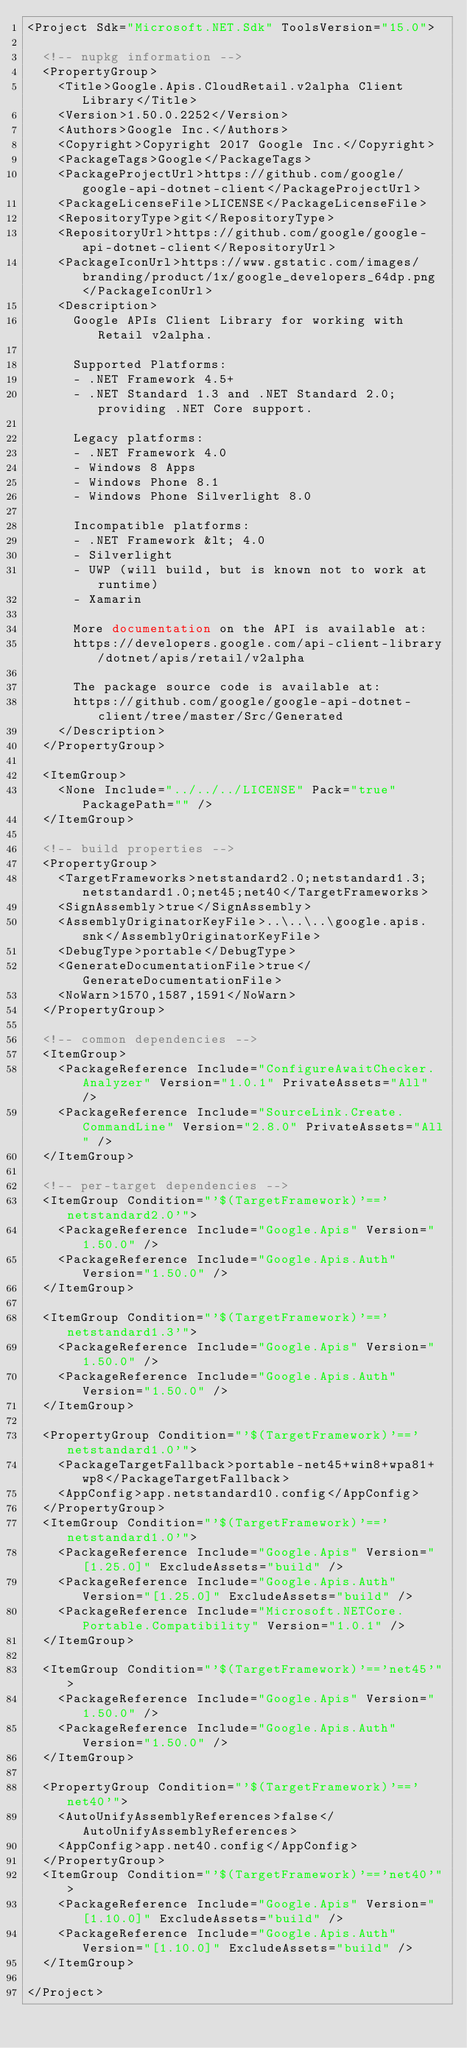<code> <loc_0><loc_0><loc_500><loc_500><_XML_><Project Sdk="Microsoft.NET.Sdk" ToolsVersion="15.0">

  <!-- nupkg information -->
  <PropertyGroup>
    <Title>Google.Apis.CloudRetail.v2alpha Client Library</Title>
    <Version>1.50.0.2252</Version>
    <Authors>Google Inc.</Authors>
    <Copyright>Copyright 2017 Google Inc.</Copyright>
    <PackageTags>Google</PackageTags>
    <PackageProjectUrl>https://github.com/google/google-api-dotnet-client</PackageProjectUrl>
    <PackageLicenseFile>LICENSE</PackageLicenseFile>
    <RepositoryType>git</RepositoryType>
    <RepositoryUrl>https://github.com/google/google-api-dotnet-client</RepositoryUrl>
    <PackageIconUrl>https://www.gstatic.com/images/branding/product/1x/google_developers_64dp.png</PackageIconUrl>
    <Description>
      Google APIs Client Library for working with Retail v2alpha.

      Supported Platforms:
      - .NET Framework 4.5+
      - .NET Standard 1.3 and .NET Standard 2.0; providing .NET Core support.

      Legacy platforms:
      - .NET Framework 4.0
      - Windows 8 Apps
      - Windows Phone 8.1
      - Windows Phone Silverlight 8.0

      Incompatible platforms:
      - .NET Framework &lt; 4.0
      - Silverlight
      - UWP (will build, but is known not to work at runtime)
      - Xamarin

      More documentation on the API is available at:
      https://developers.google.com/api-client-library/dotnet/apis/retail/v2alpha

      The package source code is available at:
      https://github.com/google/google-api-dotnet-client/tree/master/Src/Generated
    </Description>
  </PropertyGroup>

  <ItemGroup>
    <None Include="../../../LICENSE" Pack="true" PackagePath="" />
  </ItemGroup>

  <!-- build properties -->
  <PropertyGroup>
    <TargetFrameworks>netstandard2.0;netstandard1.3;netstandard1.0;net45;net40</TargetFrameworks>
    <SignAssembly>true</SignAssembly>
    <AssemblyOriginatorKeyFile>..\..\..\google.apis.snk</AssemblyOriginatorKeyFile>
    <DebugType>portable</DebugType>
    <GenerateDocumentationFile>true</GenerateDocumentationFile>
    <NoWarn>1570,1587,1591</NoWarn>
  </PropertyGroup>

  <!-- common dependencies -->
  <ItemGroup>
    <PackageReference Include="ConfigureAwaitChecker.Analyzer" Version="1.0.1" PrivateAssets="All" />
    <PackageReference Include="SourceLink.Create.CommandLine" Version="2.8.0" PrivateAssets="All" />
  </ItemGroup>

  <!-- per-target dependencies -->
  <ItemGroup Condition="'$(TargetFramework)'=='netstandard2.0'">
    <PackageReference Include="Google.Apis" Version="1.50.0" />
    <PackageReference Include="Google.Apis.Auth" Version="1.50.0" />
  </ItemGroup>

  <ItemGroup Condition="'$(TargetFramework)'=='netstandard1.3'">
    <PackageReference Include="Google.Apis" Version="1.50.0" />
    <PackageReference Include="Google.Apis.Auth" Version="1.50.0" />
  </ItemGroup>

  <PropertyGroup Condition="'$(TargetFramework)'=='netstandard1.0'">
    <PackageTargetFallback>portable-net45+win8+wpa81+wp8</PackageTargetFallback>
    <AppConfig>app.netstandard10.config</AppConfig>
  </PropertyGroup>
  <ItemGroup Condition="'$(TargetFramework)'=='netstandard1.0'">
    <PackageReference Include="Google.Apis" Version="[1.25.0]" ExcludeAssets="build" />
    <PackageReference Include="Google.Apis.Auth" Version="[1.25.0]" ExcludeAssets="build" />
    <PackageReference Include="Microsoft.NETCore.Portable.Compatibility" Version="1.0.1" />
  </ItemGroup>

  <ItemGroup Condition="'$(TargetFramework)'=='net45'">
    <PackageReference Include="Google.Apis" Version="1.50.0" />
    <PackageReference Include="Google.Apis.Auth" Version="1.50.0" />
  </ItemGroup>

  <PropertyGroup Condition="'$(TargetFramework)'=='net40'">
    <AutoUnifyAssemblyReferences>false</AutoUnifyAssemblyReferences>
    <AppConfig>app.net40.config</AppConfig>
  </PropertyGroup>
  <ItemGroup Condition="'$(TargetFramework)'=='net40'">
    <PackageReference Include="Google.Apis" Version="[1.10.0]" ExcludeAssets="build" />
    <PackageReference Include="Google.Apis.Auth" Version="[1.10.0]" ExcludeAssets="build" />
  </ItemGroup>

</Project>
</code> 